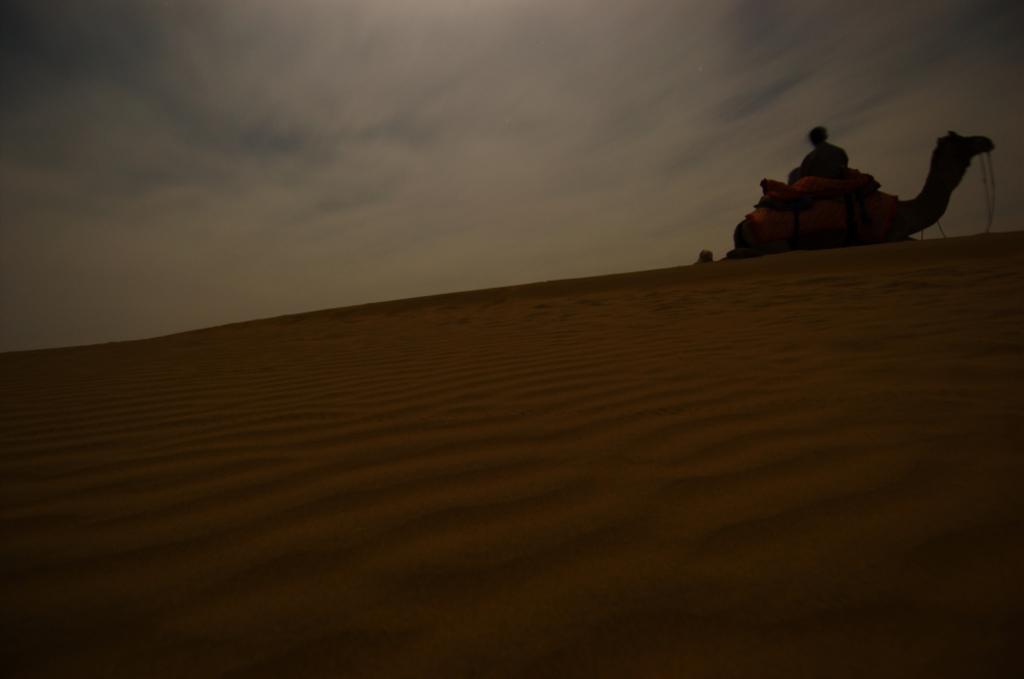What type of environment is shown in the image? The image depicts a desert. What animal can be seen in the desert? There is a camel laying on the sand in the image. Is there a person visible in the image? Yes, there is a person behind the sand in the image. What type of prison can be seen in the image? There is no prison present in the image; it depicts a desert with a camel and a person. What kind of box is visible in the image? There is no box present in the image. 